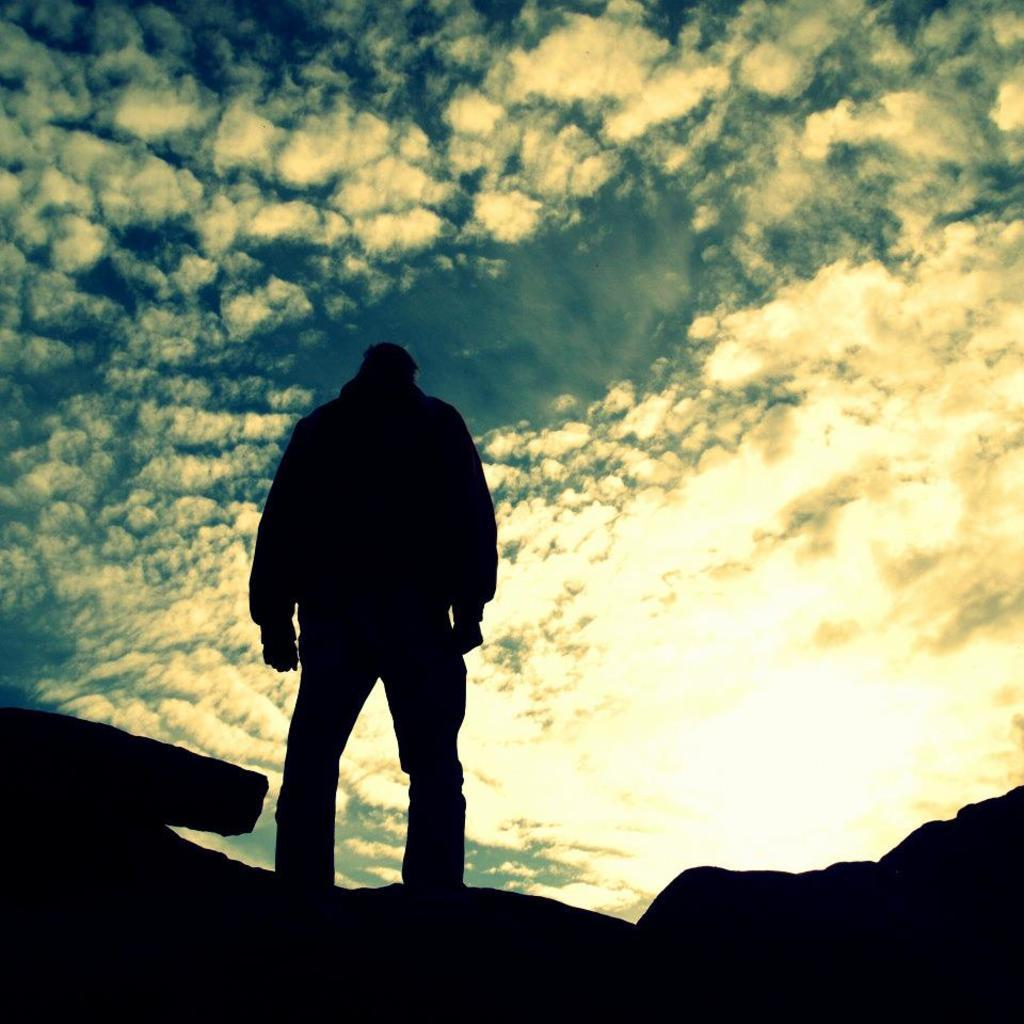What is the main subject of the image? There is a person standing in the image. What can be seen in the background of the image? The sky is visible in the background of the image. Where are the kittens playing in the image? There are no kittens present in the image. What type of boot is the person wearing in the image? The image does not show the person's footwear, so it cannot be determined if they are wearing a boot or any other type of footwear. 